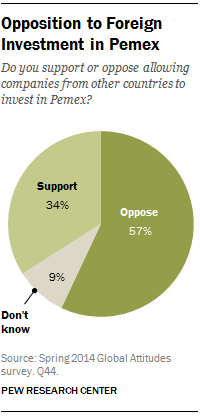Point out several critical features in this image. The sum of the largest and smallest sections is 66. The value of the largest pie section is 57. 